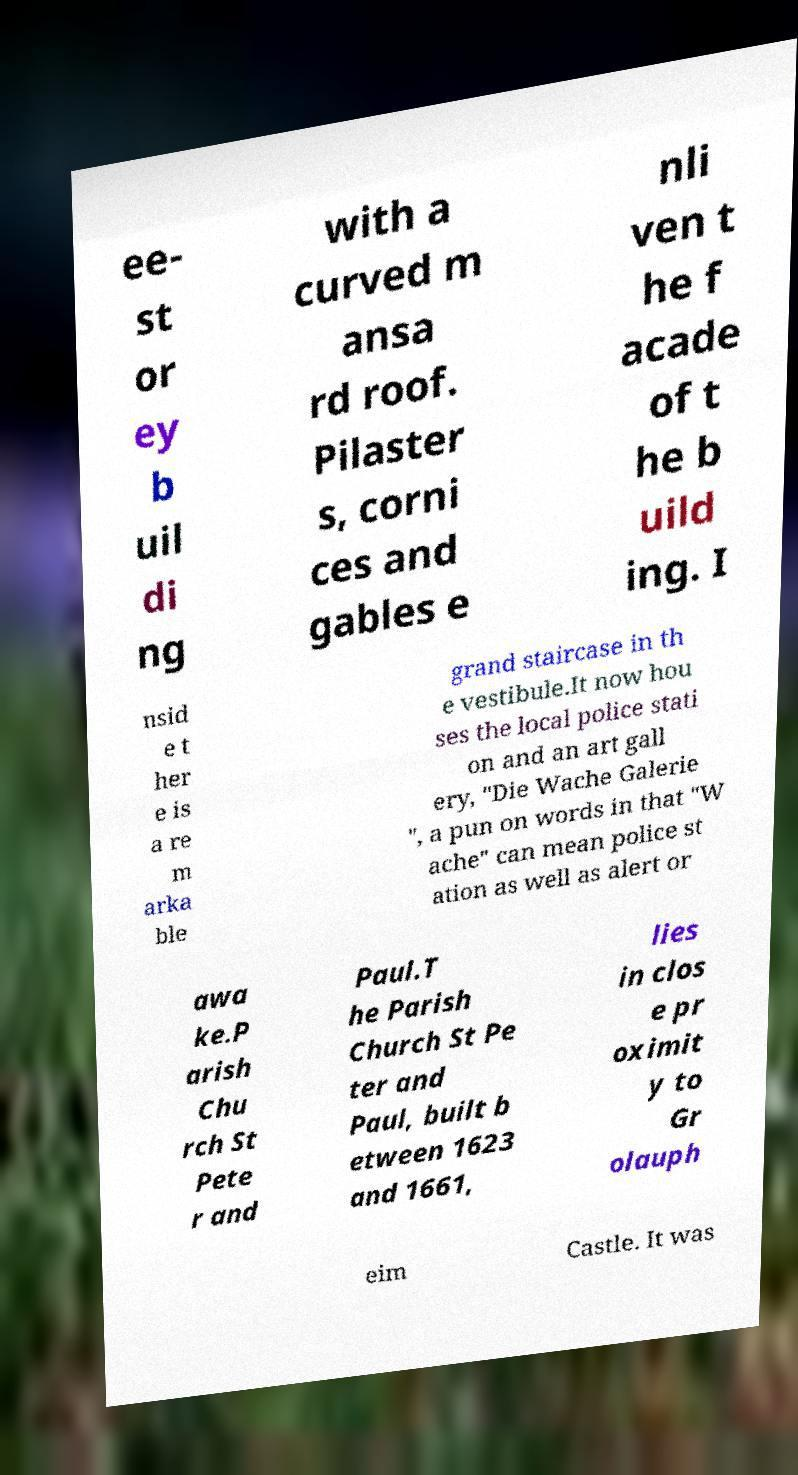Can you read and provide the text displayed in the image?This photo seems to have some interesting text. Can you extract and type it out for me? ee- st or ey b uil di ng with a curved m ansa rd roof. Pilaster s, corni ces and gables e nli ven t he f acade of t he b uild ing. I nsid e t her e is a re m arka ble grand staircase in th e vestibule.It now hou ses the local police stati on and an art gall ery, "Die Wache Galerie ", a pun on words in that "W ache" can mean police st ation as well as alert or awa ke.P arish Chu rch St Pete r and Paul.T he Parish Church St Pe ter and Paul, built b etween 1623 and 1661, lies in clos e pr oximit y to Gr olauph eim Castle. It was 